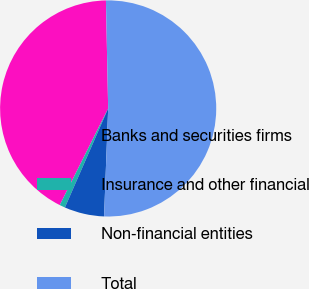<chart> <loc_0><loc_0><loc_500><loc_500><pie_chart><fcel>Banks and securities firms<fcel>Insurance and other financial<fcel>Non-financial entities<fcel>Total<nl><fcel>42.28%<fcel>0.84%<fcel>5.95%<fcel>50.93%<nl></chart> 